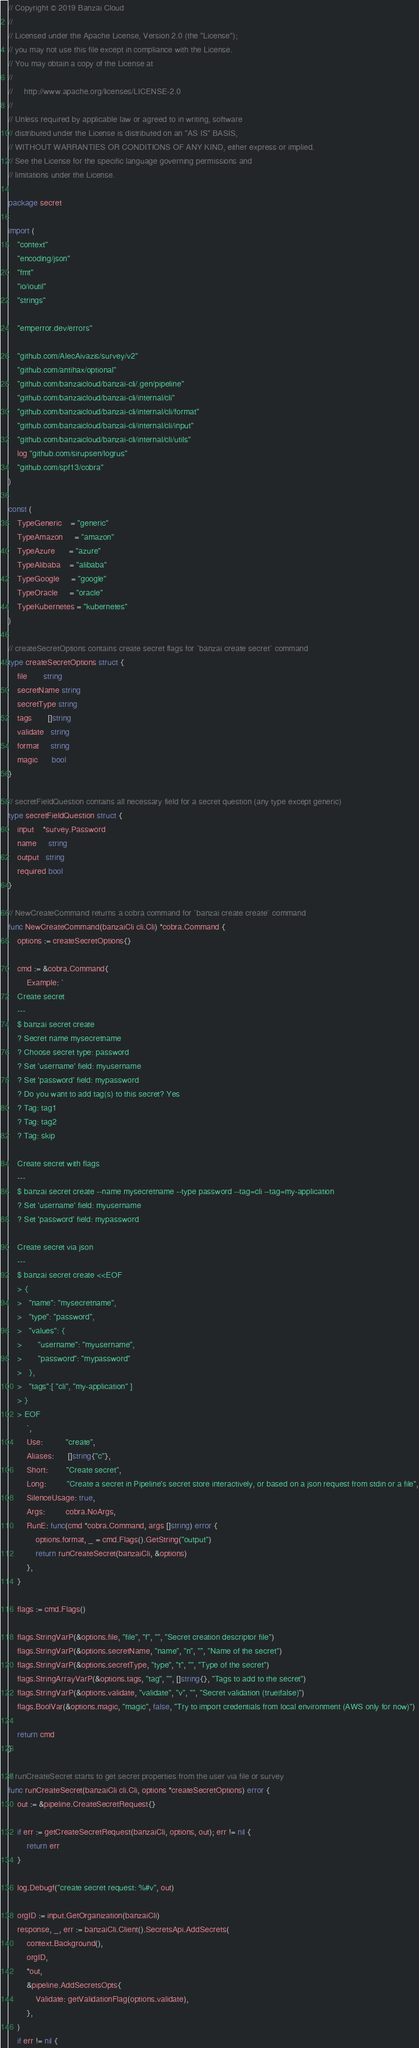<code> <loc_0><loc_0><loc_500><loc_500><_Go_>// Copyright © 2019 Banzai Cloud
//
// Licensed under the Apache License, Version 2.0 (the "License");
// you may not use this file except in compliance with the License.
// You may obtain a copy of the License at
//
//     http://www.apache.org/licenses/LICENSE-2.0
//
// Unless required by applicable law or agreed to in writing, software
// distributed under the License is distributed on an "AS IS" BASIS,
// WITHOUT WARRANTIES OR CONDITIONS OF ANY KIND, either express or implied.
// See the License for the specific language governing permissions and
// limitations under the License.

package secret

import (
	"context"
	"encoding/json"
	"fmt"
	"io/ioutil"
	"strings"

	"emperror.dev/errors"

	"github.com/AlecAivazis/survey/v2"
	"github.com/antihax/optional"
	"github.com/banzaicloud/banzai-cli/.gen/pipeline"
	"github.com/banzaicloud/banzai-cli/internal/cli"
	"github.com/banzaicloud/banzai-cli/internal/cli/format"
	"github.com/banzaicloud/banzai-cli/internal/cli/input"
	"github.com/banzaicloud/banzai-cli/internal/cli/utils"
	log "github.com/sirupsen/logrus"
	"github.com/spf13/cobra"
)

const (
	TypeGeneric    = "generic"
	TypeAmazon     = "amazon"
	TypeAzure      = "azure"
	TypeAlibaba    = "alibaba"
	TypeGoogle     = "google"
	TypeOracle     = "oracle"
	TypeKubernetes = "kubernetes"
)

// createSecretOptions contains create secret flags for `banzai create secret` command
type createSecretOptions struct {
	file       string
	secretName string
	secretType string
	tags       []string
	validate   string
	format     string
	magic      bool
}

// secretFieldQuestion contains all necessary field for a secret question (any type except generic)
type secretFieldQuestion struct {
	input    *survey.Password
	name     string
	output   string
	required bool
}

// NewCreateCommand returns a cobra command for `banzai create create` command
func NewCreateCommand(banzaiCli cli.Cli) *cobra.Command {
	options := createSecretOptions{}

	cmd := &cobra.Command{
		Example: `
	Create secret
	---
	$ banzai secret create
	? Secret name mysecretname
	? Choose secret type: password
	? Set 'username' field: myusername
	? Set 'password' field: mypassword
	? Do you want to add tag(s) to this secret? Yes
	? Tag: tag1
	? Tag: tag2
	? Tag: skip

	Create secret with flags
	---
	$ banzai secret create --name mysecretname --type password --tag=cli --tag=my-application
	? Set 'username' field: myusername
	? Set 'password' field: mypassword

	Create secret via json
	---
	$ banzai secret create <<EOF
	> {
	>	"name": "mysecretname",
	>	"type": "password",
	>	"values": {
	>		"username": "myusername",
	>		"password": "mypassword"
	>	},
	>	"tags":[ "cli", "my-application" ]
	> }
	> EOF
		`,
		Use:          "create",
		Aliases:      []string{"c"},
		Short:        "Create secret",
		Long:         "Create a secret in Pipeline's secret store interactively, or based on a json request from stdin or a file",
		SilenceUsage: true,
		Args:         cobra.NoArgs,
		RunE: func(cmd *cobra.Command, args []string) error {
			options.format, _ = cmd.Flags().GetString("output")
			return runCreateSecret(banzaiCli, &options)
		},
	}

	flags := cmd.Flags()

	flags.StringVarP(&options.file, "file", "f", "", "Secret creation descriptor file")
	flags.StringVarP(&options.secretName, "name", "n", "", "Name of the secret")
	flags.StringVarP(&options.secretType, "type", "t", "", "Type of the secret")
	flags.StringArrayVarP(&options.tags, "tag", "", []string{}, "Tags to add to the secret")
	flags.StringVarP(&options.validate, "validate", "v", "", "Secret validation (true|false)")
	flags.BoolVar(&options.magic, "magic", false, "Try to import credentials from local environment (AWS only for now)")

	return cmd
}

// runCreateSecret starts to get secret properties from the user via file or survey
func runCreateSecret(banzaiCli cli.Cli, options *createSecretOptions) error {
	out := &pipeline.CreateSecretRequest{}

	if err := getCreateSecretRequest(banzaiCli, options, out); err != nil {
		return err
	}

	log.Debugf("create secret request: %#v", out)

	orgID := input.GetOrganization(banzaiCli)
	response, _, err := banzaiCli.Client().SecretsApi.AddSecrets(
		context.Background(),
		orgID,
		*out,
		&pipeline.AddSecretsOpts{
			Validate: getValidationFlag(options.validate),
		},
	)
	if err != nil {</code> 